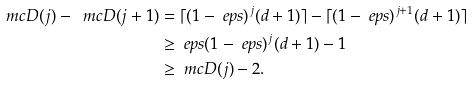Convert formula to latex. <formula><loc_0><loc_0><loc_500><loc_500>\ m c { D } ( j ) - \ m c { D } ( j + 1 ) & = \lceil ( 1 - \ e p s ) ^ { j } ( d + 1 ) \rceil - \lceil ( 1 - \ e p s ) ^ { j + 1 } ( d + 1 ) \rceil \\ & \geq \ e p s ( 1 - \ e p s ) ^ { j } ( d + 1 ) - 1 \\ & \geq \ m c { D } ( j ) - 2 .</formula> 